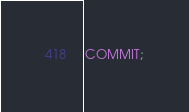Convert code to text. <code><loc_0><loc_0><loc_500><loc_500><_SQL_>
COMMIT;</code> 